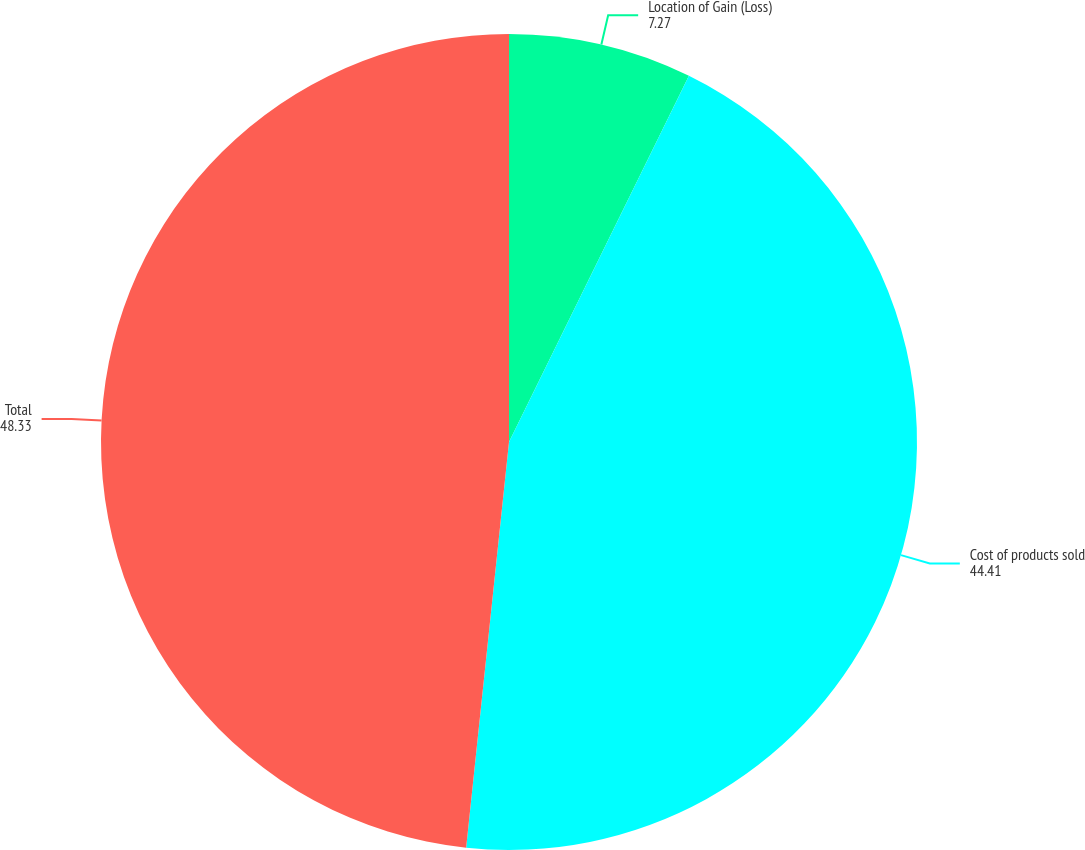Convert chart. <chart><loc_0><loc_0><loc_500><loc_500><pie_chart><fcel>Location of Gain (Loss)<fcel>Cost of products sold<fcel>Total<nl><fcel>7.27%<fcel>44.41%<fcel>48.33%<nl></chart> 